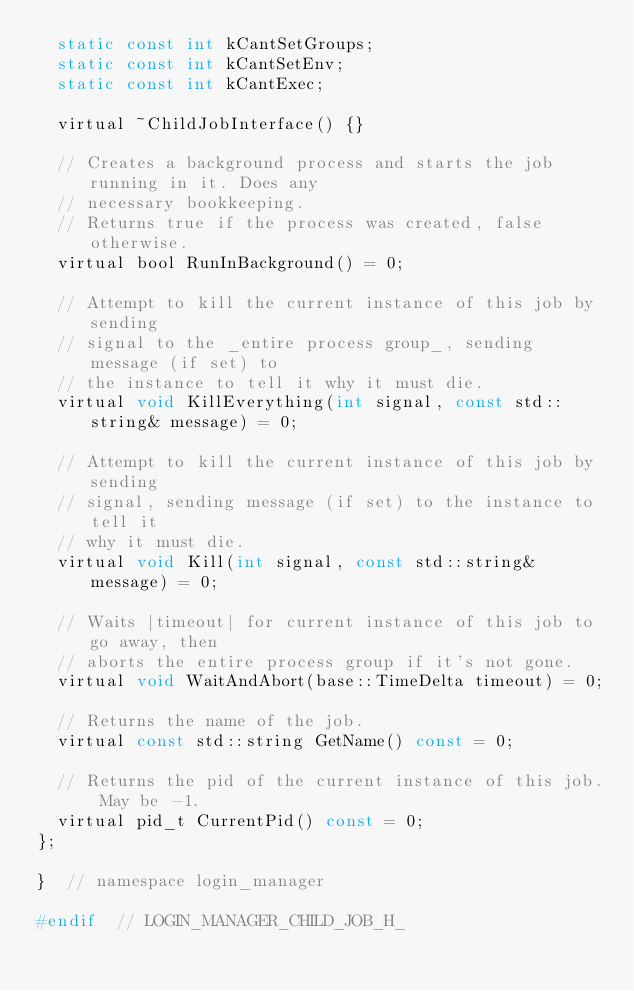<code> <loc_0><loc_0><loc_500><loc_500><_C_>  static const int kCantSetGroups;
  static const int kCantSetEnv;
  static const int kCantExec;

  virtual ~ChildJobInterface() {}

  // Creates a background process and starts the job running in it. Does any
  // necessary bookkeeping.
  // Returns true if the process was created, false otherwise.
  virtual bool RunInBackground() = 0;

  // Attempt to kill the current instance of this job by sending
  // signal to the _entire process group_, sending message (if set) to
  // the instance to tell it why it must die.
  virtual void KillEverything(int signal, const std::string& message) = 0;

  // Attempt to kill the current instance of this job by sending
  // signal, sending message (if set) to the instance to tell it
  // why it must die.
  virtual void Kill(int signal, const std::string& message) = 0;

  // Waits |timeout| for current instance of this job to go away, then
  // aborts the entire process group if it's not gone.
  virtual void WaitAndAbort(base::TimeDelta timeout) = 0;

  // Returns the name of the job.
  virtual const std::string GetName() const = 0;

  // Returns the pid of the current instance of this job. May be -1.
  virtual pid_t CurrentPid() const = 0;
};

}  // namespace login_manager

#endif  // LOGIN_MANAGER_CHILD_JOB_H_
</code> 